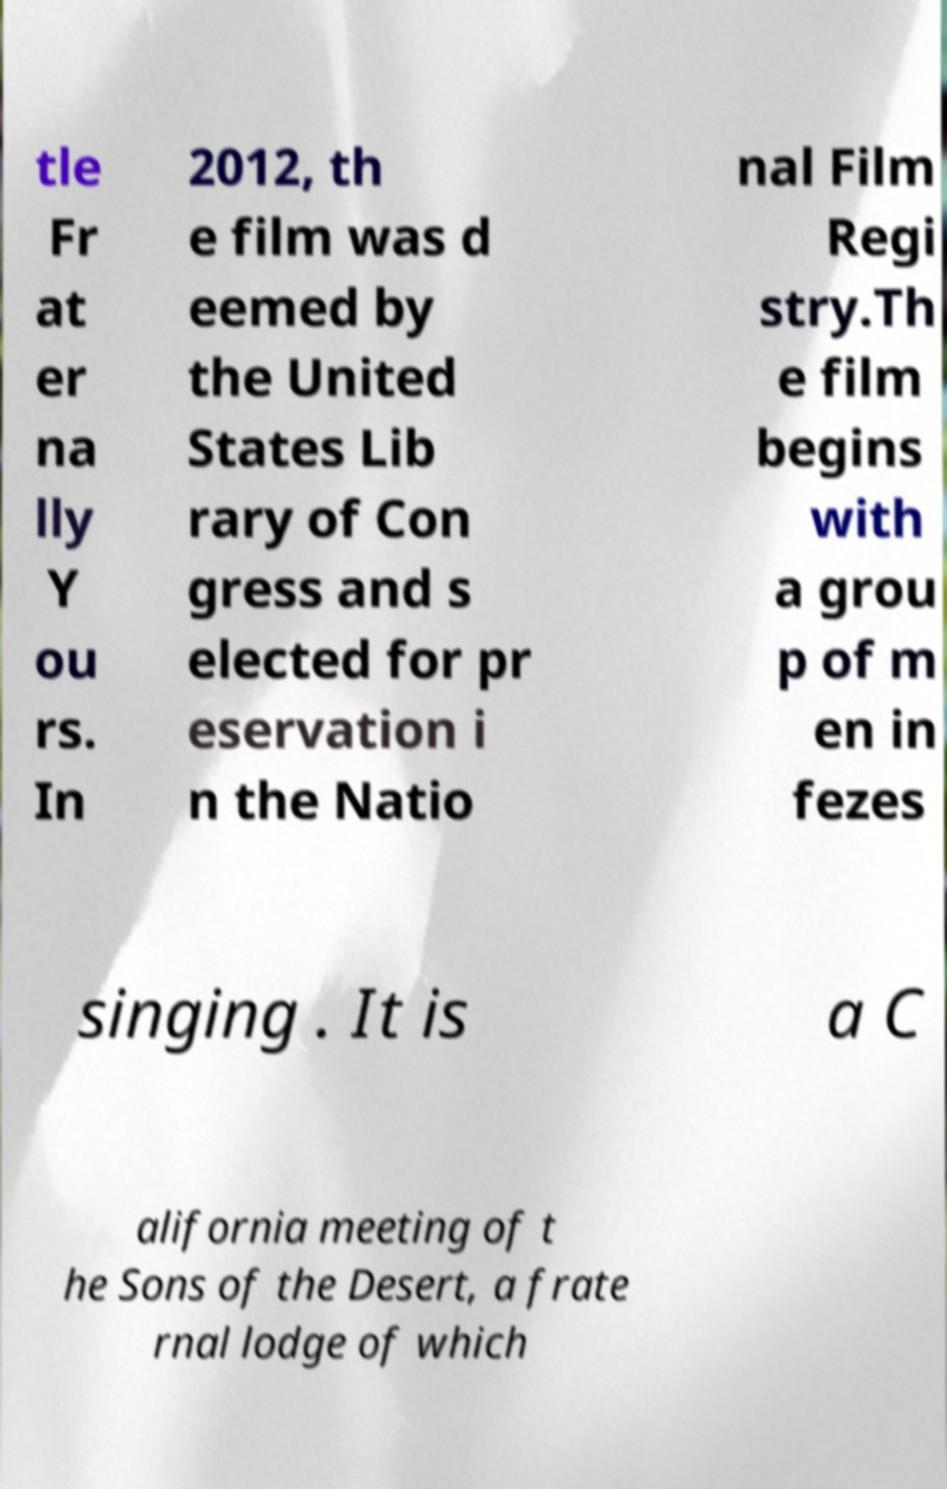Could you extract and type out the text from this image? tle Fr at er na lly Y ou rs. In 2012, th e film was d eemed by the United States Lib rary of Con gress and s elected for pr eservation i n the Natio nal Film Regi stry.Th e film begins with a grou p of m en in fezes singing . It is a C alifornia meeting of t he Sons of the Desert, a frate rnal lodge of which 